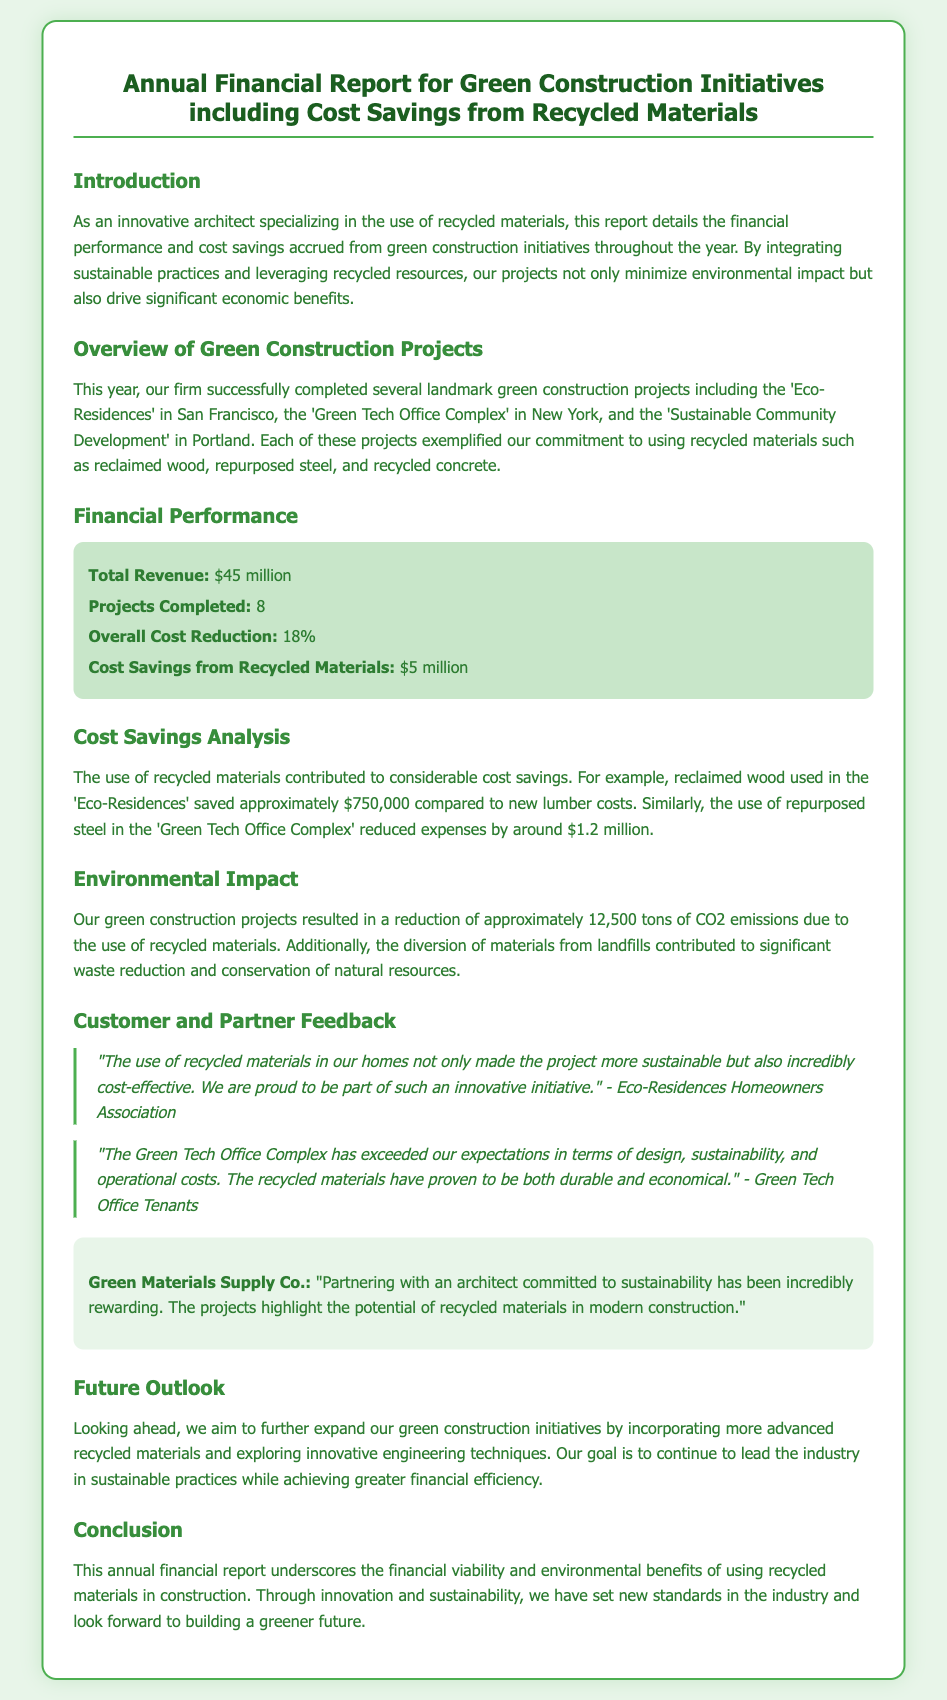what is the total revenue? The total revenue is mentioned in the financial performance section, indicating the income generated from all projects.
Answer: $45 million how many projects were completed? The document lists the number of completed projects in the financial performance section.
Answer: 8 what is the overall cost reduction percentage? This information is specified in the financial performance section and indicates the efficiency achieved through green initiatives.
Answer: 18% how much cost savings were achieved from recycled materials? The document explicitly states the total cost savings derived from using recycled materials in the financial performance section.
Answer: $5 million what is the CO2 emissions reduction amount? The environmental impact section specifies the total reduction in CO2 emissions resulting from the projects.
Answer: 12,500 tons which project saved approximately $750,000? The cost savings analysis identifies the project related to this specific savings when using recycled materials.
Answer: Eco-Residences what feedback was provided by the Eco-Residences Homeowners Association? This inquiry pertains to the testimonials of customer feedback presented in the document, indicating their satisfaction.
Answer: "The use of recycled materials in our homes not only made the project more sustainable but also incredibly cost-effective." what are the future goals for green construction initiatives? The future outlook section outlines the aspirations of the organization in expanding sustainable practices and materials.
Answer: Incorporating more advanced recycled materials and exploring innovative engineering techniques 